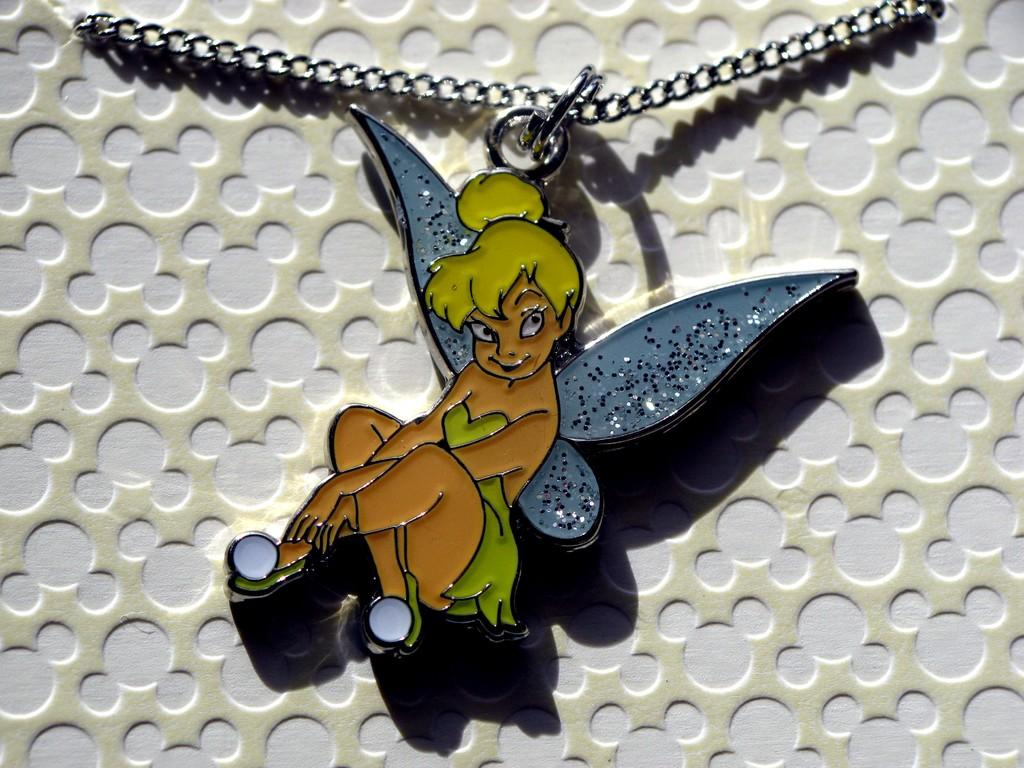What is the main object in the middle of the image? There is a toy in the middle of the image. What else is present in the middle of the image? There is a chain in the middle of the image. What colors can be seen in the background of the image? The background of the image includes white and cream colors. What arithmetic problem is being solved on the toy in the image? There is no arithmetic problem visible on the toy in the image. How does the substance affect the toy in the image? There is no substance affecting the toy in the image. 